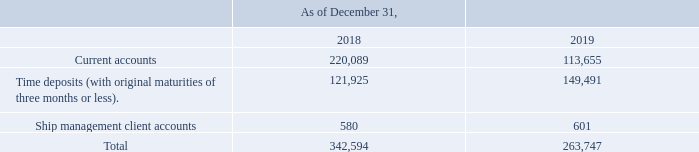GasLog Ltd. and its Subsidiaries
Notes to the consolidated financial statements (Continued)
For the years ended December 31, 2017, 2018 and 2019
(All amounts expressed in thousands of U.S. Dollars, except share and per share data)
8. Cash and Cash Equivalents
Cash and cash equivalents consist of the following:
Ship management client accounts represent amounts provided by the clients of GasLog LNG Services Ltd. in order to enable the Group to cover obligations of vessels under management. A compensating balance is held as a current liability.
In which years was the cash and cash equivalents recorded for? 2018, 2019. What does ship management client accounts represent? Ship management client accounts represent amounts provided by the clients of gaslog lng services ltd. in order to enable the group to cover obligations of vessels under management. What was the amount of ship management client accounts in 2018?
Answer scale should be: thousand. 580. In which year was the time deposits higher? 149,491 > 121,925
Answer: 2019. What was the change in current accounts  from 2018 to 2019?
Answer scale should be: thousand. 113,655 - 220,089 
Answer: -106434. What was the percentage change in total cash and cash equivalents from 2018 to 2019?
Answer scale should be: percent. (263,747 - 342,594)/342,594 
Answer: -23.01. 